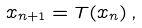<formula> <loc_0><loc_0><loc_500><loc_500>x _ { n + 1 } = T ( x _ { n } ) \, ,</formula> 